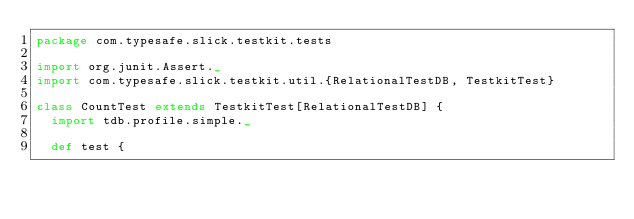Convert code to text. <code><loc_0><loc_0><loc_500><loc_500><_Scala_>package com.typesafe.slick.testkit.tests

import org.junit.Assert._
import com.typesafe.slick.testkit.util.{RelationalTestDB, TestkitTest}

class CountTest extends TestkitTest[RelationalTestDB] {
  import tdb.profile.simple._

  def test {</code> 